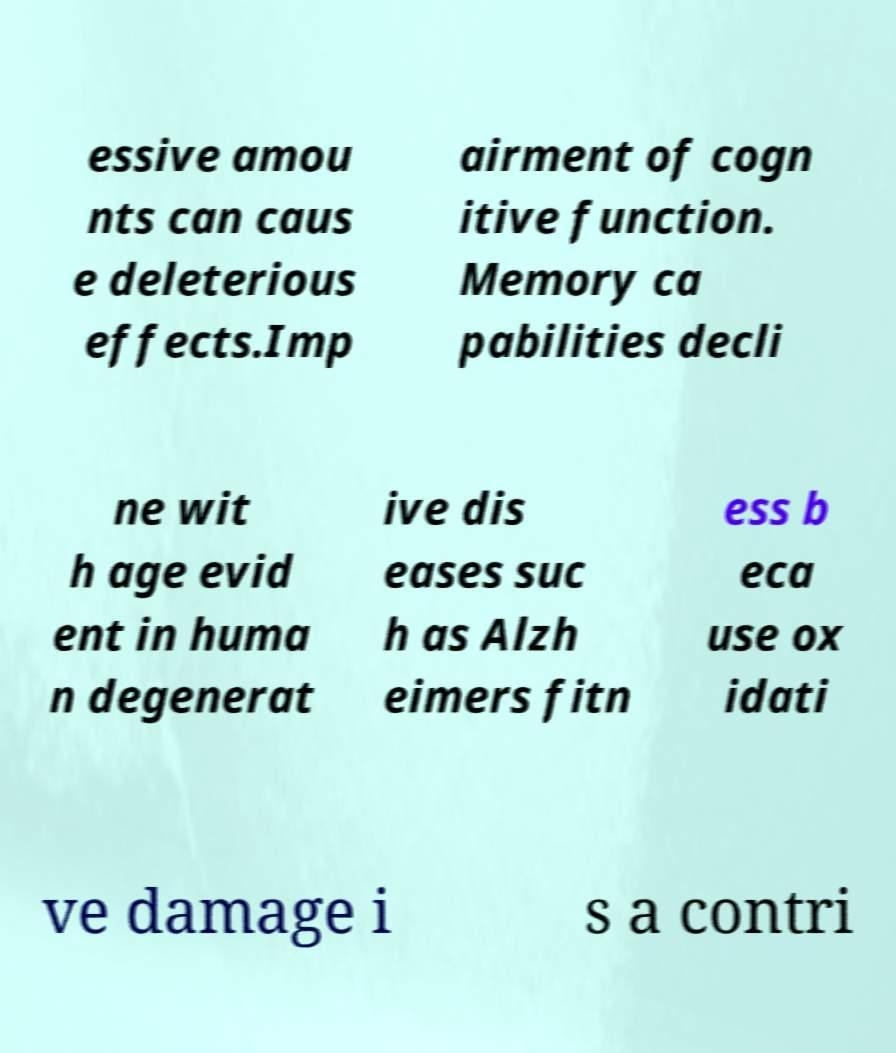Could you extract and type out the text from this image? essive amou nts can caus e deleterious effects.Imp airment of cogn itive function. Memory ca pabilities decli ne wit h age evid ent in huma n degenerat ive dis eases suc h as Alzh eimers fitn ess b eca use ox idati ve damage i s a contri 